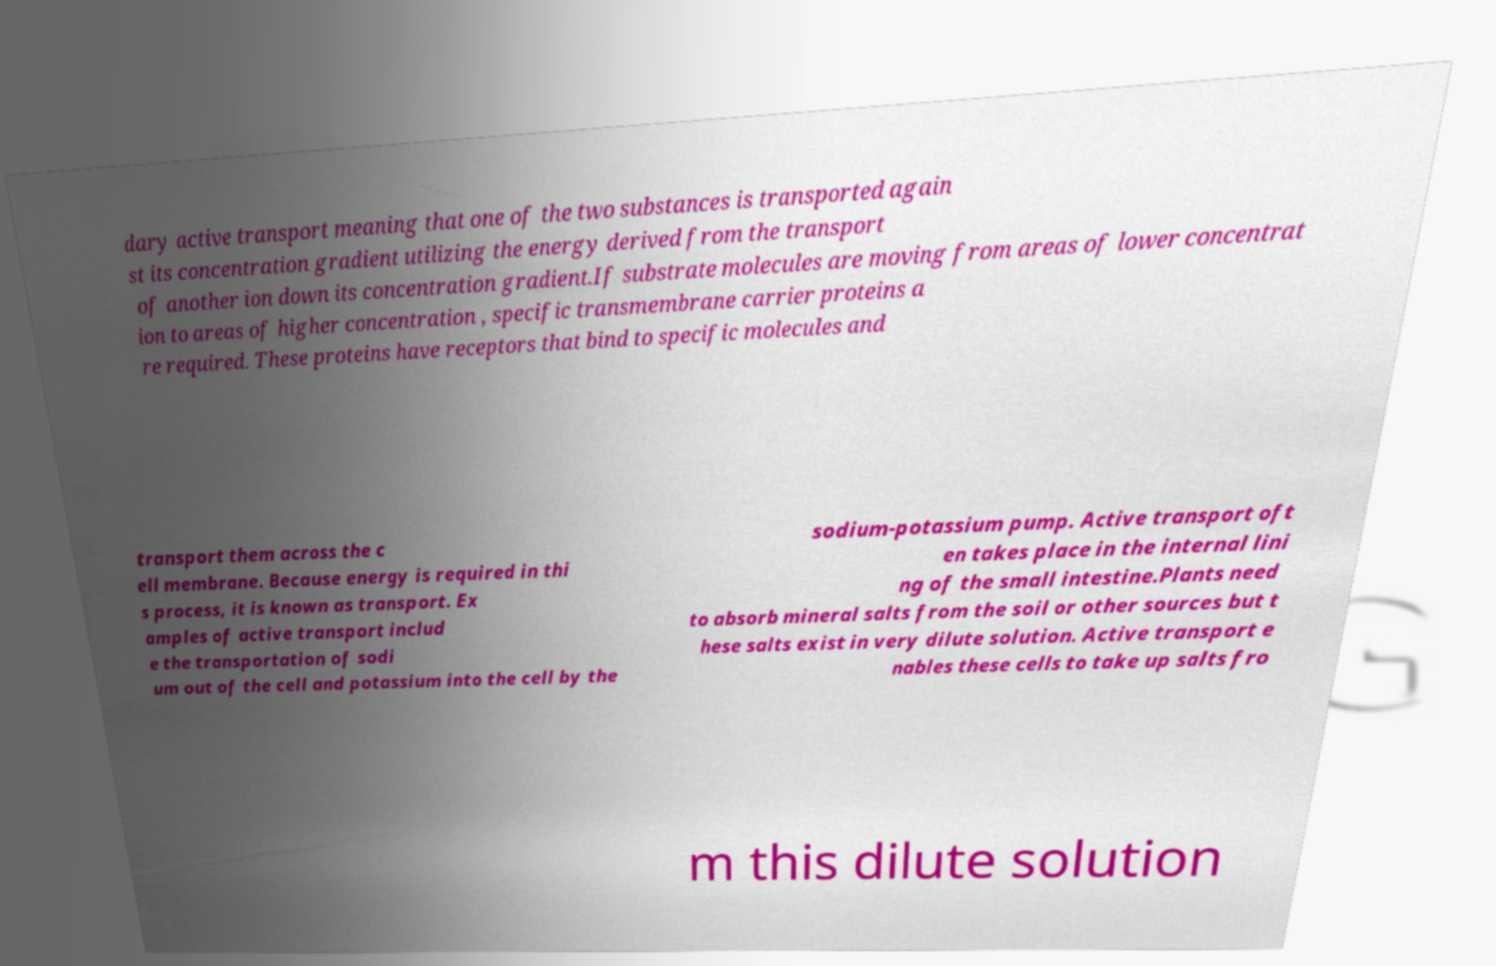Can you accurately transcribe the text from the provided image for me? dary active transport meaning that one of the two substances is transported again st its concentration gradient utilizing the energy derived from the transport of another ion down its concentration gradient.If substrate molecules are moving from areas of lower concentrat ion to areas of higher concentration , specific transmembrane carrier proteins a re required. These proteins have receptors that bind to specific molecules and transport them across the c ell membrane. Because energy is required in thi s process, it is known as transport. Ex amples of active transport includ e the transportation of sodi um out of the cell and potassium into the cell by the sodium-potassium pump. Active transport oft en takes place in the internal lini ng of the small intestine.Plants need to absorb mineral salts from the soil or other sources but t hese salts exist in very dilute solution. Active transport e nables these cells to take up salts fro m this dilute solution 